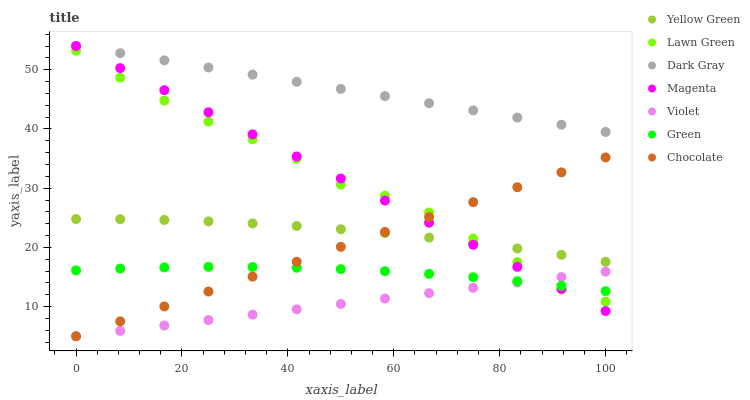Does Violet have the minimum area under the curve?
Answer yes or no. Yes. Does Dark Gray have the maximum area under the curve?
Answer yes or no. Yes. Does Yellow Green have the minimum area under the curve?
Answer yes or no. No. Does Yellow Green have the maximum area under the curve?
Answer yes or no. No. Is Violet the smoothest?
Answer yes or no. Yes. Is Lawn Green the roughest?
Answer yes or no. Yes. Is Yellow Green the smoothest?
Answer yes or no. No. Is Yellow Green the roughest?
Answer yes or no. No. Does Chocolate have the lowest value?
Answer yes or no. Yes. Does Yellow Green have the lowest value?
Answer yes or no. No. Does Magenta have the highest value?
Answer yes or no. Yes. Does Yellow Green have the highest value?
Answer yes or no. No. Is Violet less than Yellow Green?
Answer yes or no. Yes. Is Yellow Green greater than Violet?
Answer yes or no. Yes. Does Magenta intersect Yellow Green?
Answer yes or no. Yes. Is Magenta less than Yellow Green?
Answer yes or no. No. Is Magenta greater than Yellow Green?
Answer yes or no. No. Does Violet intersect Yellow Green?
Answer yes or no. No. 